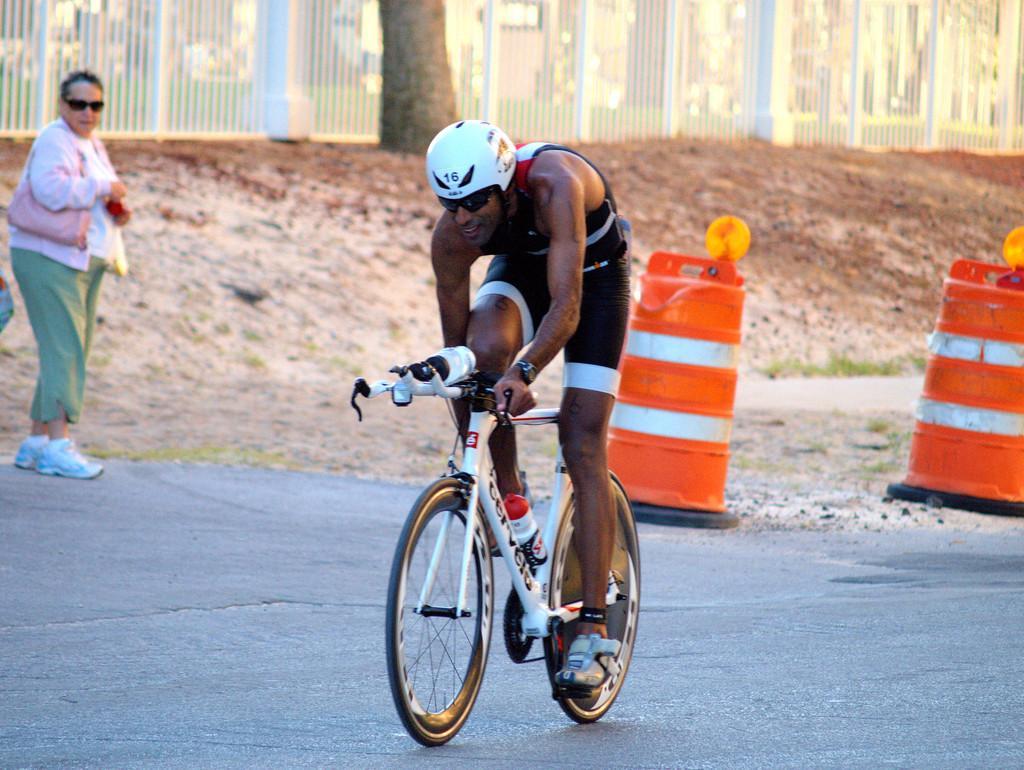Can you describe this image briefly? In the center we can see one man riding bicycle and he is wearing helmet. In the background there is a woman standing and fence,tree and traffic pole. 